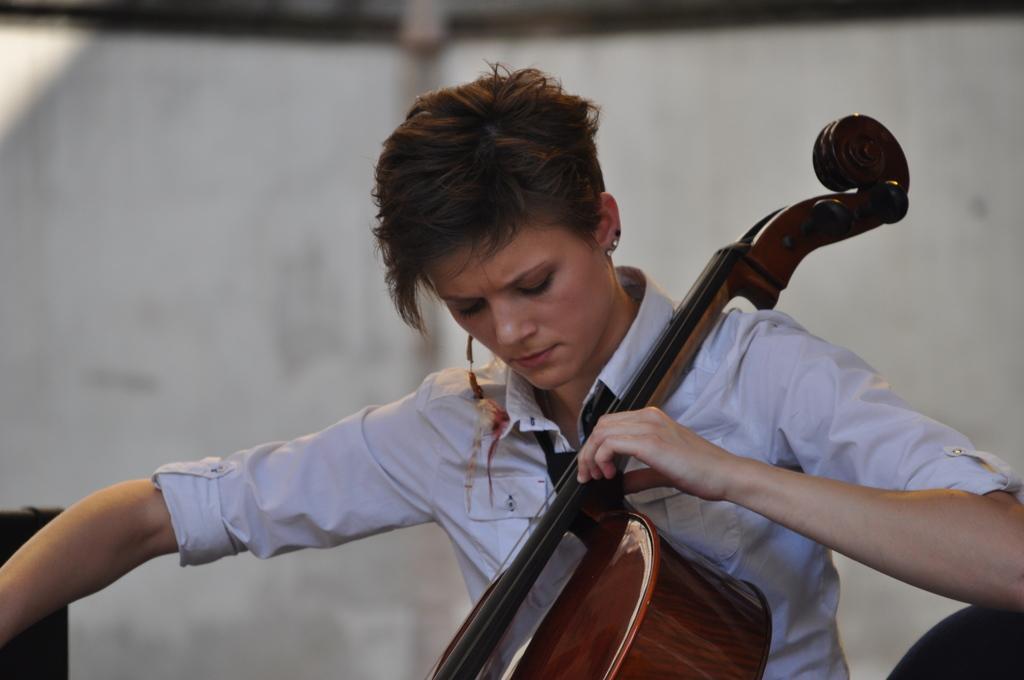In one or two sentences, can you explain what this image depicts? In the middle of the image a woman is sitting and holding a musical instrument. Behind her there is wall. 